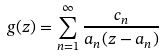<formula> <loc_0><loc_0><loc_500><loc_500>g ( z ) = \sum _ { n = 1 } ^ { \infty } \frac { c _ { n } } { a _ { n } ( z - a _ { n } ) }</formula> 